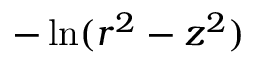<formula> <loc_0><loc_0><loc_500><loc_500>- \ln ( r ^ { 2 } - z ^ { 2 } )</formula> 